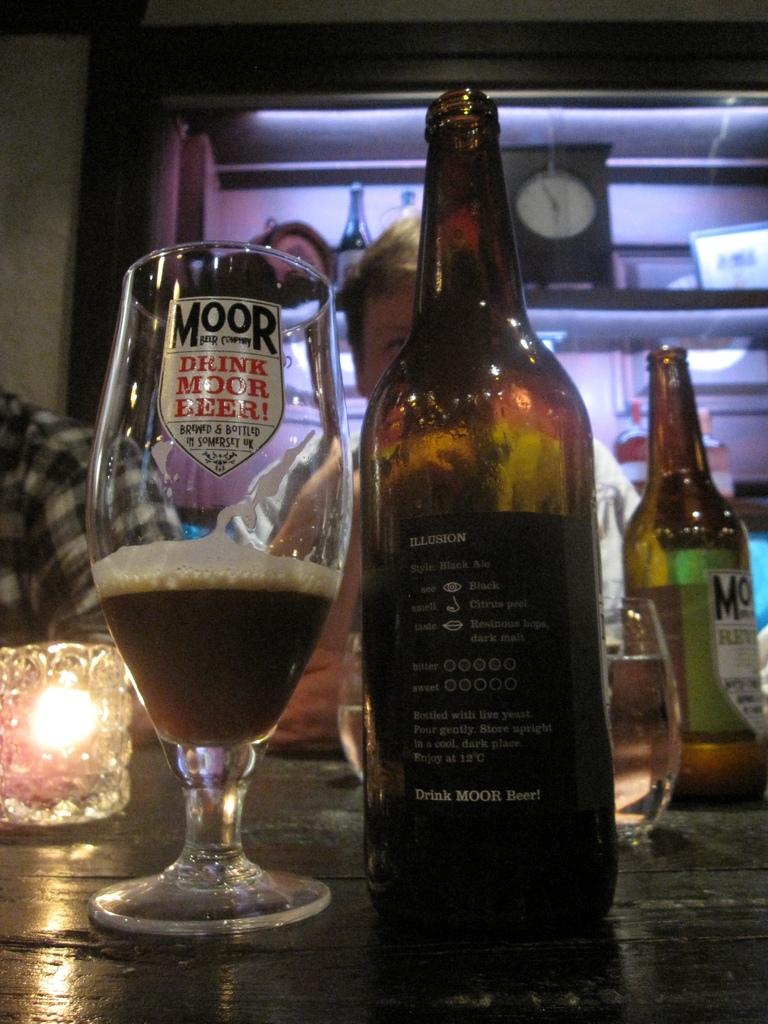What type of bottles are present in the image? There are wine bottles in the image. Can you describe the person in the image? There is a man in the image. How many slaves are depicted in the image? There are no slaves present in the image; it only features wine bottles and a man. What type of vase can be seen in the image? There is no vase present in the image. 